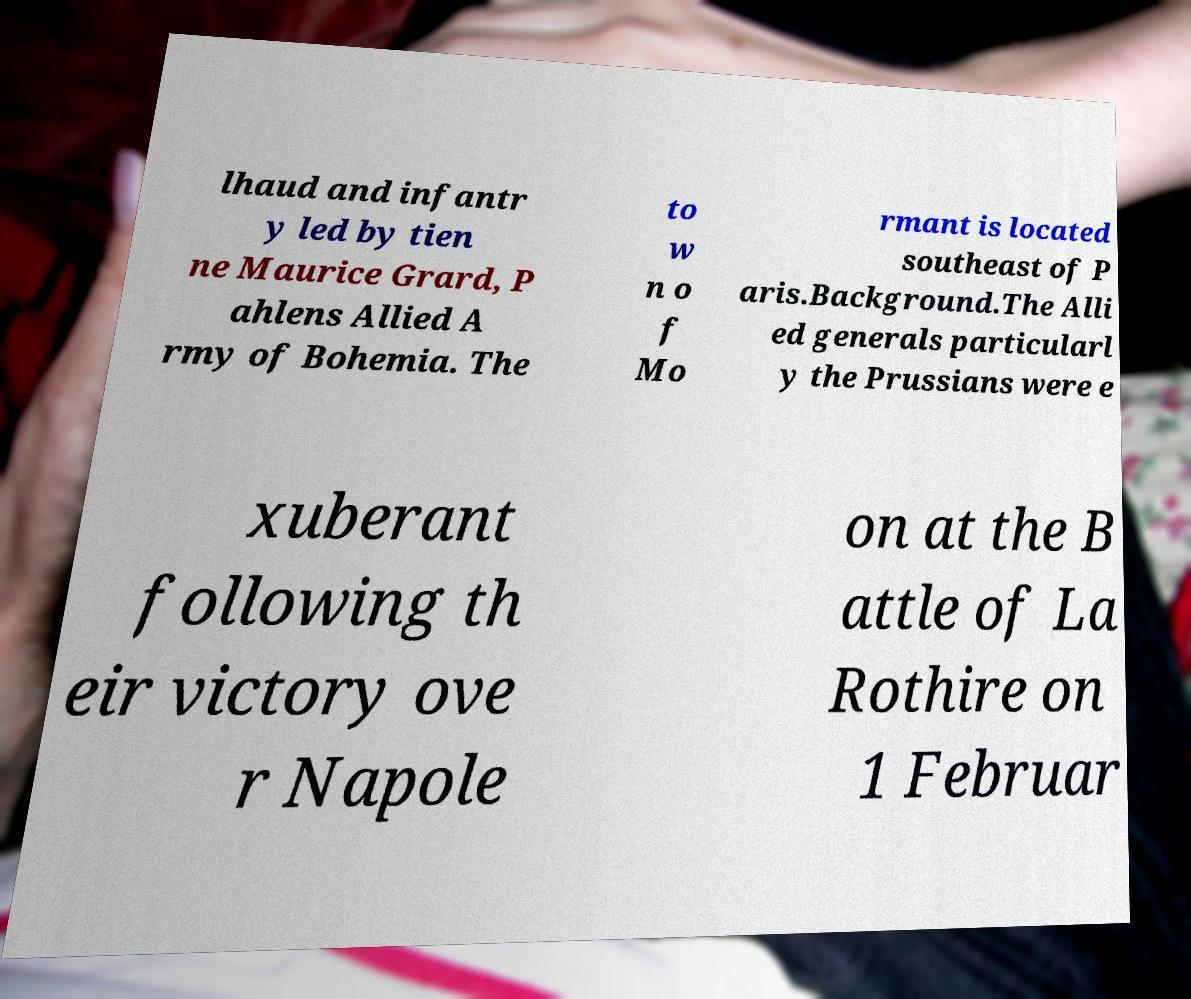What messages or text are displayed in this image? I need them in a readable, typed format. lhaud and infantr y led by tien ne Maurice Grard, P ahlens Allied A rmy of Bohemia. The to w n o f Mo rmant is located southeast of P aris.Background.The Alli ed generals particularl y the Prussians were e xuberant following th eir victory ove r Napole on at the B attle of La Rothire on 1 Februar 